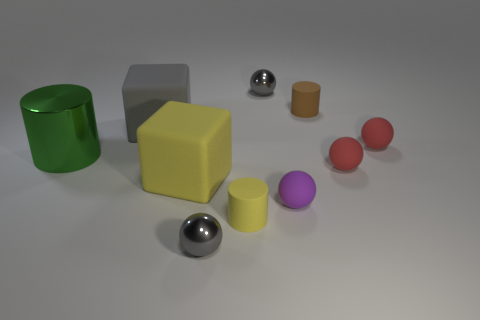Could you describe how the shadows are oriented in relation to the shapes? The shadows in the image are mostly oriented towards the right side, suggesting a light source from the left. This creates elongated shadows that extend from the base of each object, providing a visual cue about the light's direction and intensity. 